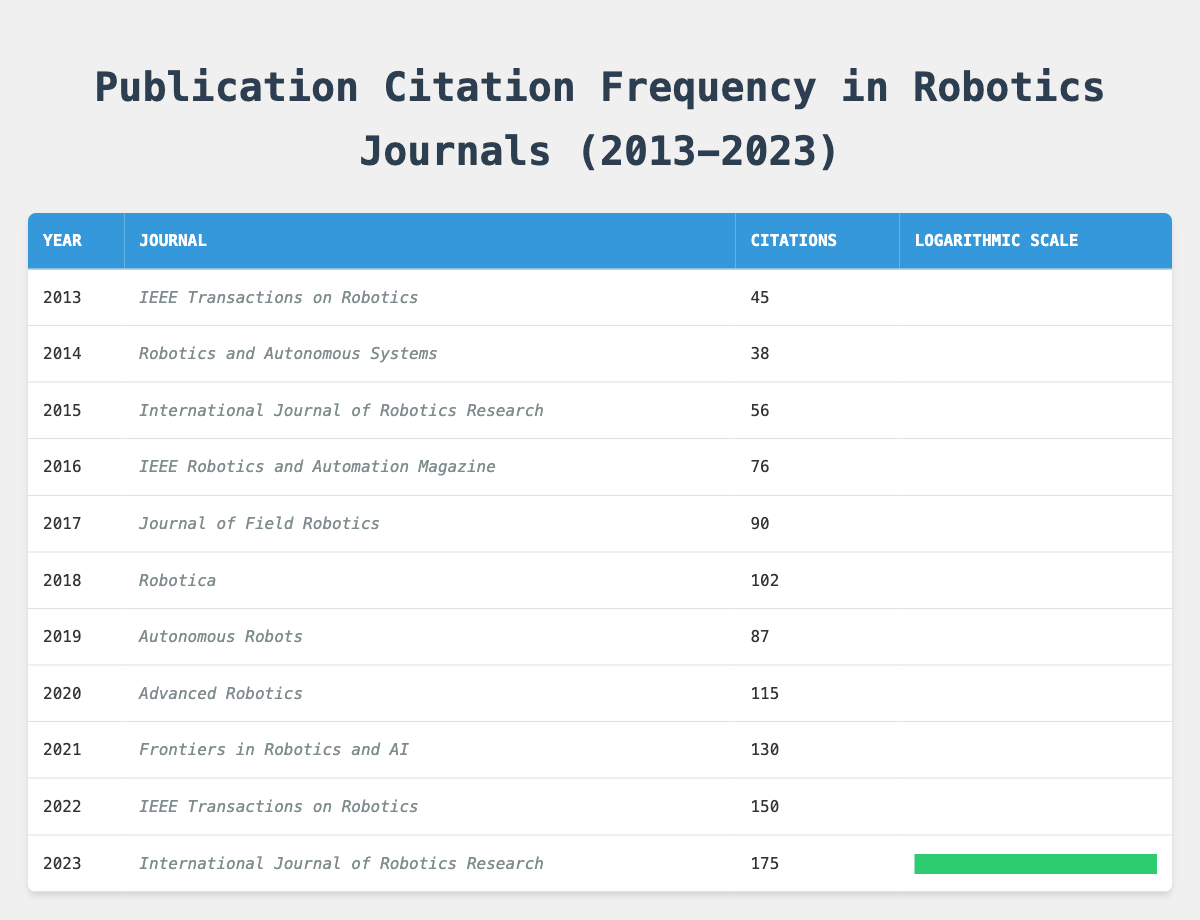What was the highest number of citations recorded in a single year? The table shows the citation counts per year. Scanning through the citations, we see 175 for the year 2023, which is the highest among all the years listed.
Answer: 175 In which journal were the most citations recorded in 2021? In the year 2021, the citations were 130 for the journal "Frontiers in Robotics and AI." This was the maximum citation count for that year.
Answer: Frontiers in Robotics and AI What is the total number of citations from 2013 to 2022? To find the total, we sum the citations from each year: 45 + 38 + 56 + 76 + 90 + 102 + 87 + 115 + 130 + 150 = 999. Therefore, the total is 999 citations for the period.
Answer: 999 Which year had a higher citation count: 2018 or 2019? The citation count for 2018 is 102 and for 2019 is 87. Since 102 is greater than 87, 2018 had a higher citation count compared to 2019.
Answer: 2018 Is the trend in citation frequency increasing over the years? By observing the table, the citation counts generally increase from 2013 (45) to 2023 (175), indicating a positive trend. Hence, the statement is true.
Answer: Yes What was the average citation count from 2013 to 2023? To calculate the average, we take the total citations (1,174 from the previous calculation) and divide by the number of years (11): 1,174/11 = approximately 107.64. Thus, the average citation count is around 107.64.
Answer: 107.64 Which journal had the least number of citations in the entire table? Scanning through each year's journal entries, "Robotics and Autonomous Systems" in 2014 had the least number of citations with a count of 38.
Answer: Robotics and Autonomous Systems Compare the citation counts of 2016 and 2017. Which was higher and by how much? The citation count for 2016 is 76 while for 2017 it is 90. To find the difference: 90 - 76 = 14, indicating that 2017 had 14 more citations than 2016.
Answer: 14 What is the median citation count across all years? The citation counts, when sorted, are: 38, 45, 56, 76, 87, 90, 102, 115, 130, 150, 175. With 11 values, the median is the 6th value, which is 90.
Answer: 90 